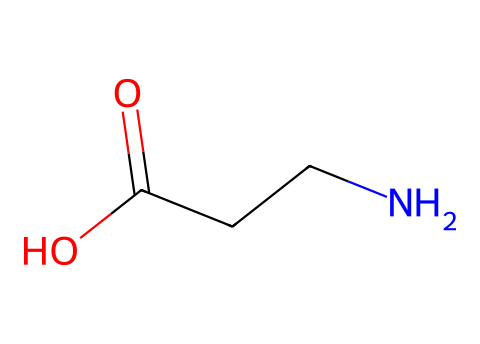What is the molecular formula of this compound? To determine the molecular formula, count the number of each type of atom present in the SMILES representation. The structure includes 3 carbon atoms (C), 7 hydrogen atoms (H), 1 nitrogen atom (N), and 2 oxygen atoms (O). Therefore, the molecular formula is C3H7NO2.
Answer: C3H7NO2 How many functional groups are present in this structure? Analyze the SMILES to identify distinct functional groups. This compound contains one carboxylic acid group (-COOH) and one amine group (-NH2), totaling two functional groups.
Answer: 2 What type of amino acid is represented by this structure? This structure is identified as a non-polar, aliphatic amino acid, which in this case is beta-alanine, due to the structure containing the amine group and being the beta amino acid.
Answer: beta-alanine Which atom in the structure contributes to its basic properties? The nitrogen atom (N) in the amine group behaves as a basic site because it can accept protons (H+) in acidic environments, allowing the molecule to act as a weak base.
Answer: nitrogen What type of isomerism can this molecule exhibit? The presence of the carboxylic acid group and the amine group allow for potential stereoisomerism, specifically, it can be represented as having an L and D configuration depending on the arrangement around the alpha carbon, though beta-alanine itself does not have chiral centers.
Answer: none What is the significance of beta-alanine in equine performance? Beta-alanine is known to enhance performance by increasing carnosine levels in muscles, which helps buffer acid during high-intensity exercise, making it significant for athletic performance.
Answer: enhances performance 